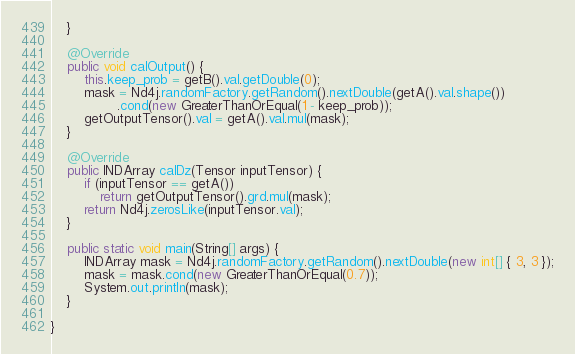<code> <loc_0><loc_0><loc_500><loc_500><_Java_>	}

	@Override
	public void calOutput() {
		this.keep_prob = getB().val.getDouble(0);
		mask = Nd4j.randomFactory.getRandom().nextDouble(getA().val.shape())
				.cond(new GreaterThanOrEqual(1 - keep_prob));
		getOutputTensor().val = getA().val.mul(mask);
	}

	@Override
	public INDArray calDz(Tensor inputTensor) {
		if (inputTensor == getA())
			return getOutputTensor().grd.mul(mask);
		return Nd4j.zerosLike(inputTensor.val);
	}

	public static void main(String[] args) {
		INDArray mask = Nd4j.randomFactory.getRandom().nextDouble(new int[] { 3, 3 });
		mask = mask.cond(new GreaterThanOrEqual(0.7));
		System.out.println(mask);
	}

}</code> 